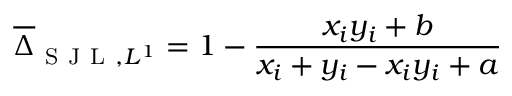<formula> <loc_0><loc_0><loc_500><loc_500>\overline { \Delta } _ { S J L , L ^ { 1 } } = 1 - \frac { x _ { i } y _ { i } + b } { x _ { i } + y _ { i } - x _ { i } y _ { i } + a }</formula> 